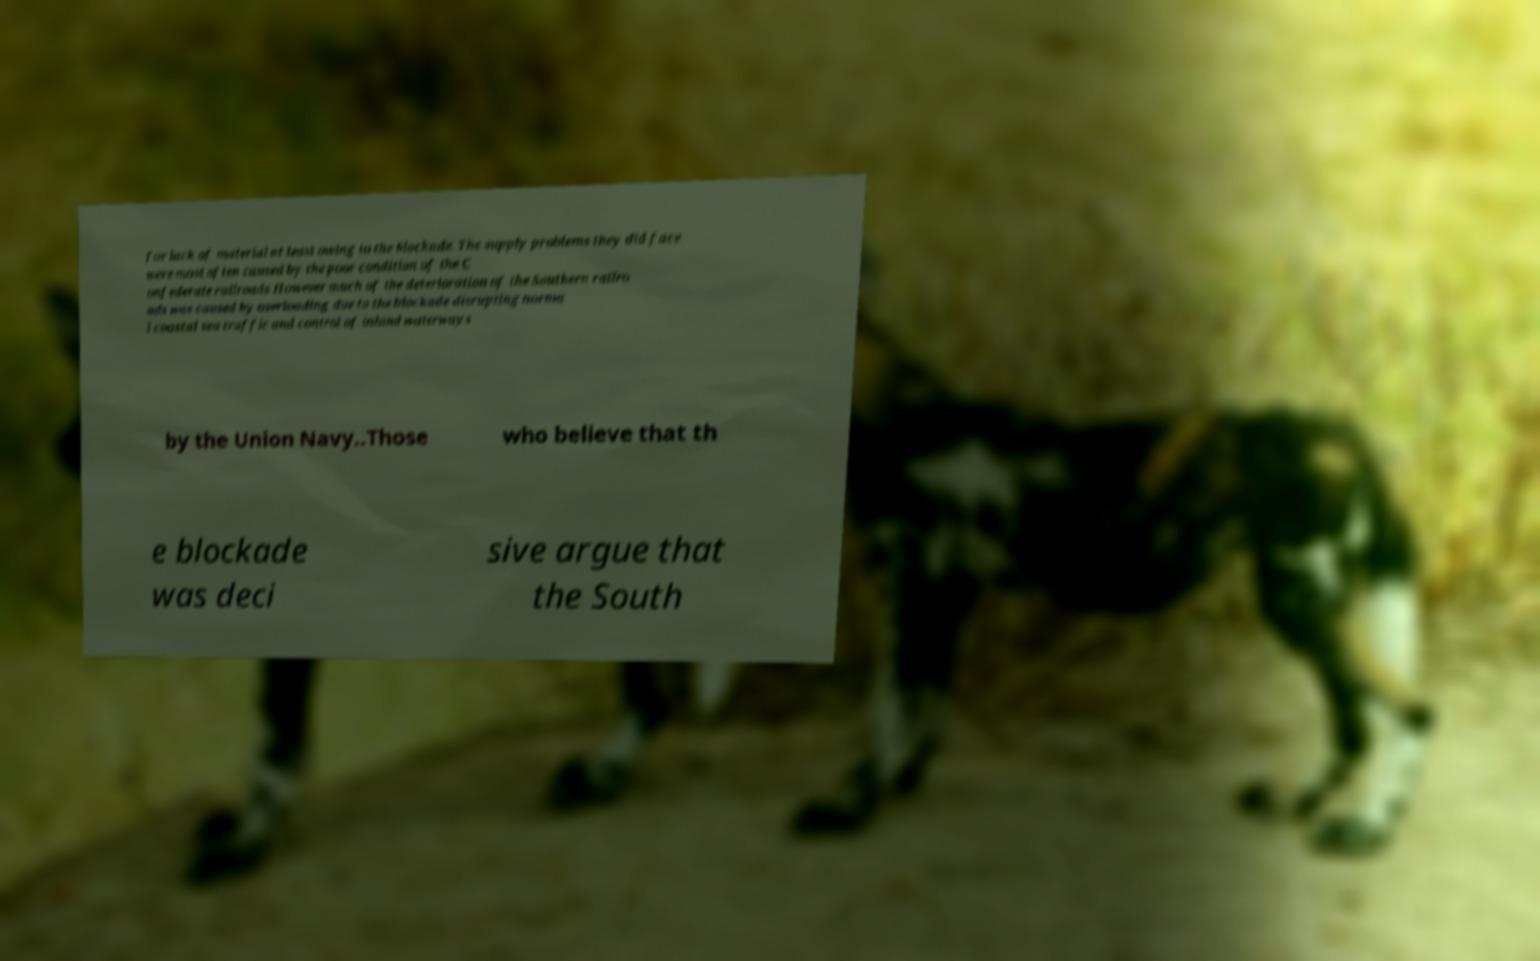Could you extract and type out the text from this image? for lack of material at least owing to the blockade. The supply problems they did face were most often caused by the poor condition of the C onfederate railroads However much of the deterioration of the Southern railro ads was caused by overloading due to the blockade disrupting norma l coastal sea traffic and control of inland waterways by the Union Navy..Those who believe that th e blockade was deci sive argue that the South 